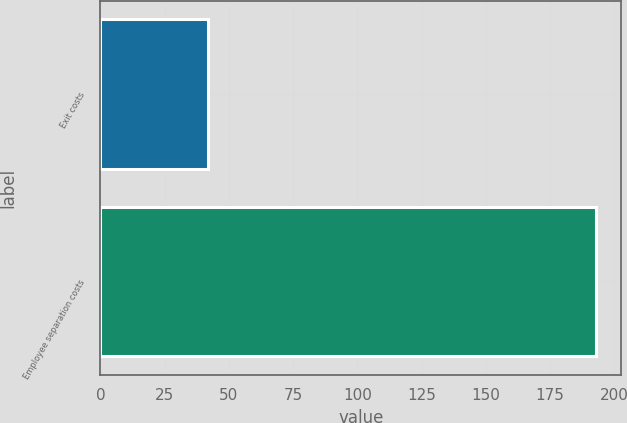Convert chart to OTSL. <chart><loc_0><loc_0><loc_500><loc_500><bar_chart><fcel>Exit costs<fcel>Employee separation costs<nl><fcel>42<fcel>193<nl></chart> 